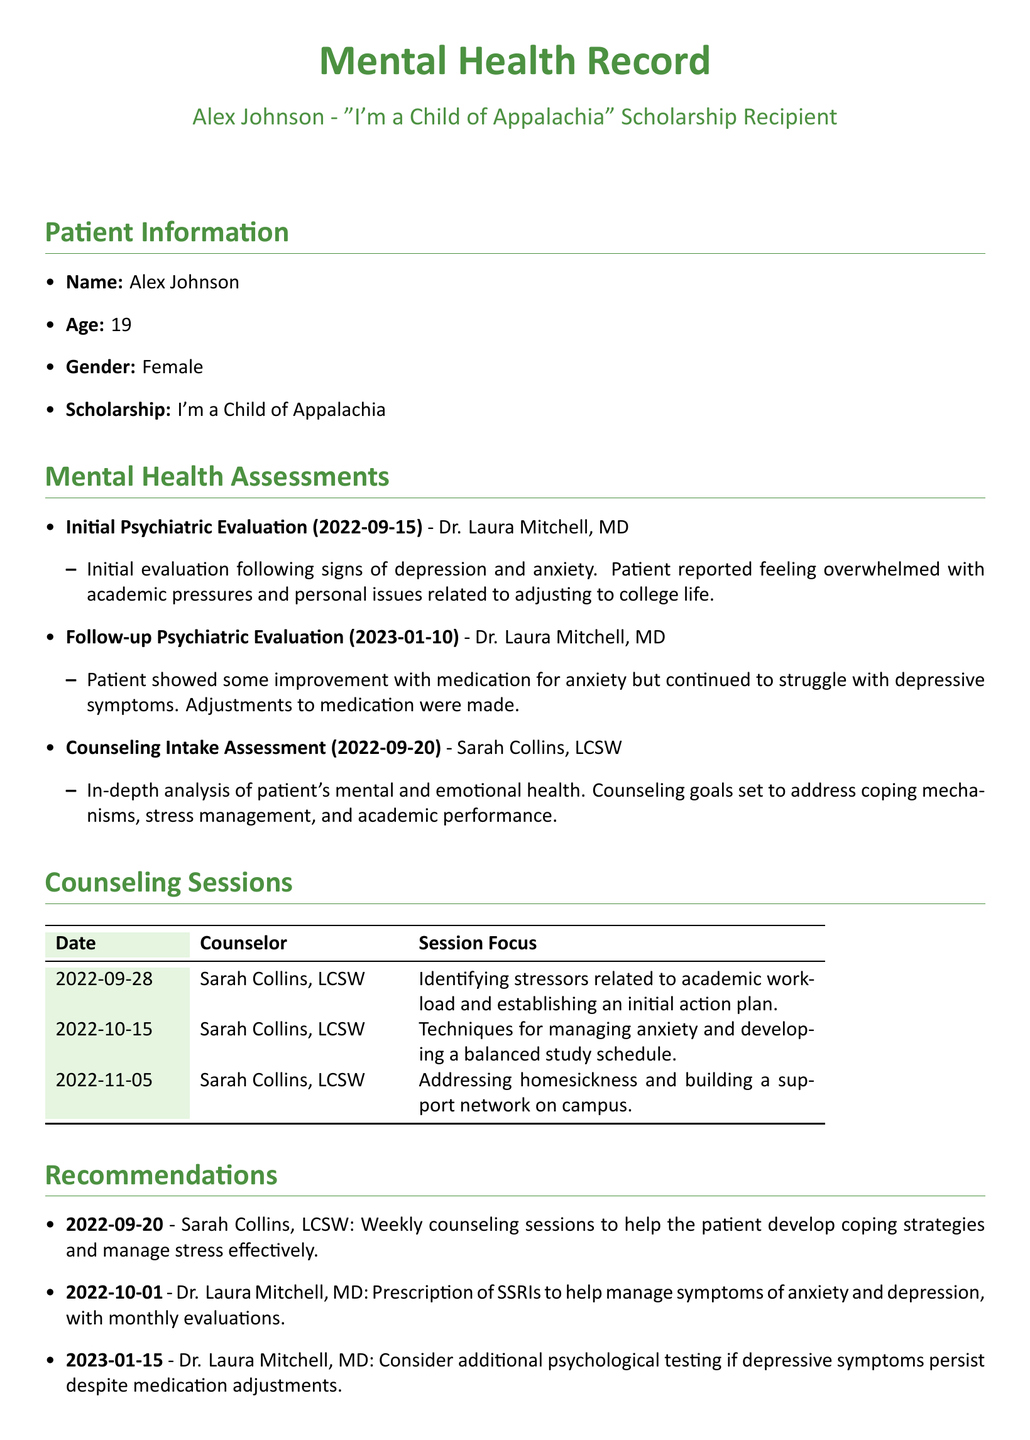What is the patient's name? The patient's name is specified in the document's Patient Information section.
Answer: Alex Johnson What date was the initial psychiatric evaluation conducted? The date of the initial evaluation is listed in the Mental Health Assessments section.
Answer: 2022-09-15 Who conducted the follow-up psychiatric evaluation? The name of the psychiatrist who conducted the follow-up evaluation is included in the Mental Health Assessments section.
Answer: Dr. Laura Mitchell, MD What was one focus of the counseling intake assessment? The document describes goals set during the counseling intake assessment, which are mentioned in the Mental Health Assessments section.
Answer: Coping mechanisms How many counseling sessions were recorded? The number of listed counseling sessions is counted in the Counseling Sessions table.
Answer: 3 What recommendation was made regarding SSRIs? The recommendation regarding SSRIs is specified in the Recommendations section.
Answer: Prescription of SSRIs When did the patient report feeling overwhelmed? The statement about feeling overwhelmed is mentioned in the context of the mental health evaluations in the document.
Answer: 2022-09-15 What issue did the patient address during the session on 2022-11-05? The issue addressed in that counseling session is outlined in the Counseling Sessions table.
Answer: Homesickness What is the patient's age? The patient's age is listed in the Patient Information section.
Answer: 19 